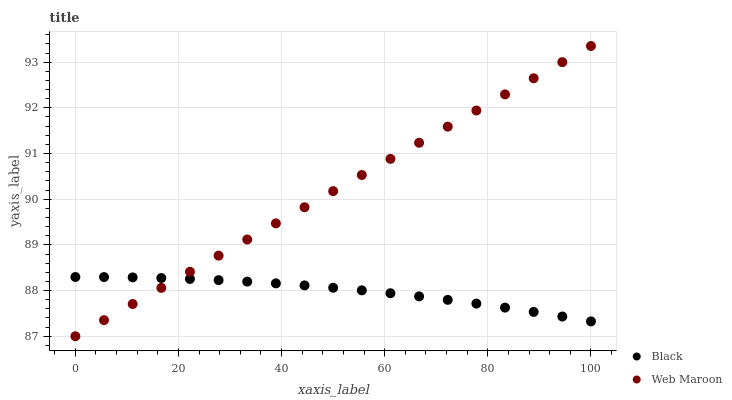Does Black have the minimum area under the curve?
Answer yes or no. Yes. Does Web Maroon have the maximum area under the curve?
Answer yes or no. Yes. Does Black have the maximum area under the curve?
Answer yes or no. No. Is Web Maroon the smoothest?
Answer yes or no. Yes. Is Black the roughest?
Answer yes or no. Yes. Is Black the smoothest?
Answer yes or no. No. Does Web Maroon have the lowest value?
Answer yes or no. Yes. Does Black have the lowest value?
Answer yes or no. No. Does Web Maroon have the highest value?
Answer yes or no. Yes. Does Black have the highest value?
Answer yes or no. No. Does Web Maroon intersect Black?
Answer yes or no. Yes. Is Web Maroon less than Black?
Answer yes or no. No. Is Web Maroon greater than Black?
Answer yes or no. No. 